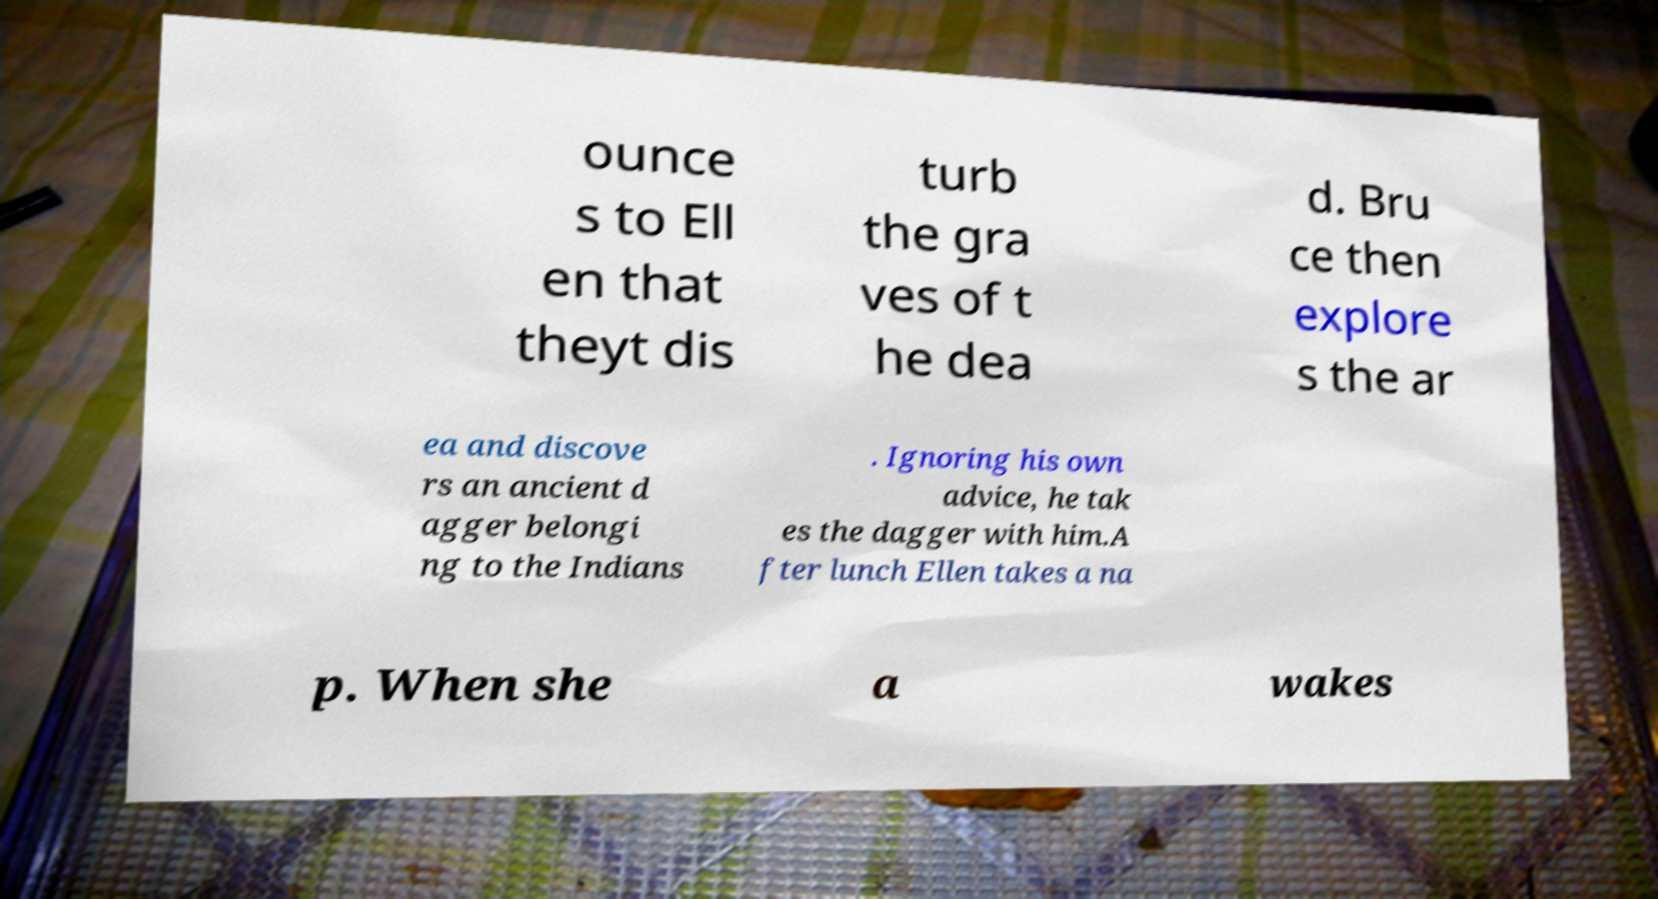What messages or text are displayed in this image? I need them in a readable, typed format. ounce s to Ell en that theyt dis turb the gra ves of t he dea d. Bru ce then explore s the ar ea and discove rs an ancient d agger belongi ng to the Indians . Ignoring his own advice, he tak es the dagger with him.A fter lunch Ellen takes a na p. When she a wakes 